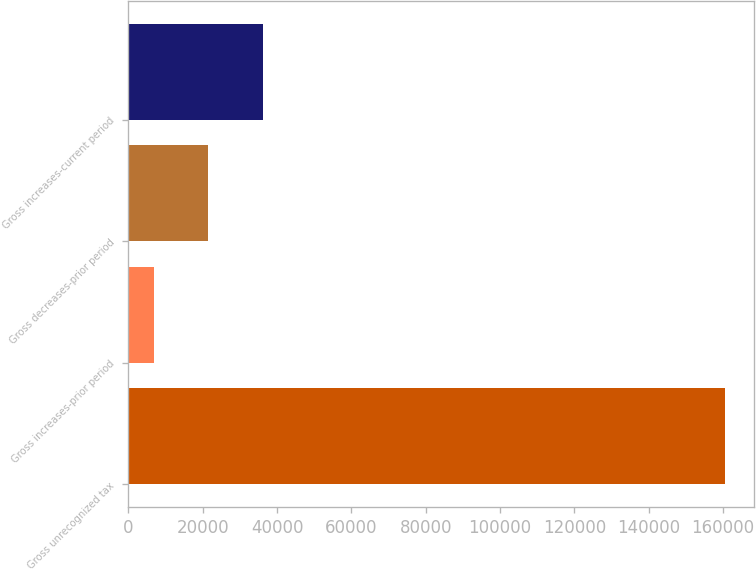Convert chart. <chart><loc_0><loc_0><loc_500><loc_500><bar_chart><fcel>Gross unrecognized tax<fcel>Gross increases-prior period<fcel>Gross decreases-prior period<fcel>Gross increases-current period<nl><fcel>160427<fcel>6903<fcel>21531.1<fcel>36159.2<nl></chart> 